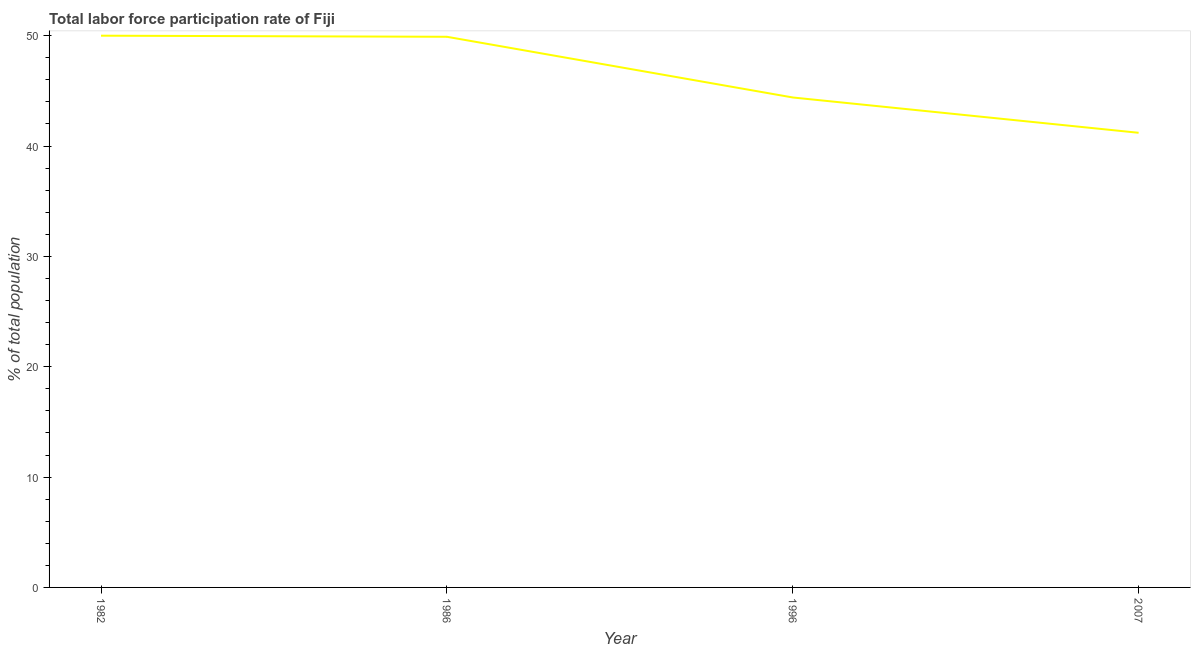What is the total labor force participation rate in 2007?
Your answer should be compact. 41.2. Across all years, what is the maximum total labor force participation rate?
Your answer should be compact. 50. Across all years, what is the minimum total labor force participation rate?
Your response must be concise. 41.2. In which year was the total labor force participation rate maximum?
Offer a very short reply. 1982. In which year was the total labor force participation rate minimum?
Make the answer very short. 2007. What is the sum of the total labor force participation rate?
Your answer should be compact. 185.5. What is the difference between the total labor force participation rate in 1982 and 1986?
Your answer should be compact. 0.1. What is the average total labor force participation rate per year?
Make the answer very short. 46.38. What is the median total labor force participation rate?
Offer a terse response. 47.15. In how many years, is the total labor force participation rate greater than 6 %?
Your response must be concise. 4. Do a majority of the years between 1986 and 2007 (inclusive) have total labor force participation rate greater than 48 %?
Provide a short and direct response. No. What is the ratio of the total labor force participation rate in 1996 to that in 2007?
Provide a short and direct response. 1.08. Is the total labor force participation rate in 1982 less than that in 2007?
Your answer should be compact. No. Is the difference between the total labor force participation rate in 1982 and 2007 greater than the difference between any two years?
Ensure brevity in your answer.  Yes. What is the difference between the highest and the second highest total labor force participation rate?
Your answer should be compact. 0.1. Is the sum of the total labor force participation rate in 1986 and 1996 greater than the maximum total labor force participation rate across all years?
Provide a succinct answer. Yes. What is the difference between the highest and the lowest total labor force participation rate?
Make the answer very short. 8.8. In how many years, is the total labor force participation rate greater than the average total labor force participation rate taken over all years?
Provide a succinct answer. 2. Does the total labor force participation rate monotonically increase over the years?
Keep it short and to the point. No. How many years are there in the graph?
Provide a succinct answer. 4. What is the difference between two consecutive major ticks on the Y-axis?
Keep it short and to the point. 10. What is the title of the graph?
Offer a terse response. Total labor force participation rate of Fiji. What is the label or title of the X-axis?
Make the answer very short. Year. What is the label or title of the Y-axis?
Offer a very short reply. % of total population. What is the % of total population of 1986?
Your answer should be compact. 49.9. What is the % of total population of 1996?
Keep it short and to the point. 44.4. What is the % of total population of 2007?
Your response must be concise. 41.2. What is the difference between the % of total population in 1982 and 2007?
Ensure brevity in your answer.  8.8. What is the difference between the % of total population in 1986 and 1996?
Your answer should be very brief. 5.5. What is the difference between the % of total population in 1996 and 2007?
Ensure brevity in your answer.  3.2. What is the ratio of the % of total population in 1982 to that in 1986?
Offer a terse response. 1. What is the ratio of the % of total population in 1982 to that in 1996?
Your response must be concise. 1.13. What is the ratio of the % of total population in 1982 to that in 2007?
Offer a terse response. 1.21. What is the ratio of the % of total population in 1986 to that in 1996?
Your answer should be compact. 1.12. What is the ratio of the % of total population in 1986 to that in 2007?
Keep it short and to the point. 1.21. What is the ratio of the % of total population in 1996 to that in 2007?
Offer a terse response. 1.08. 